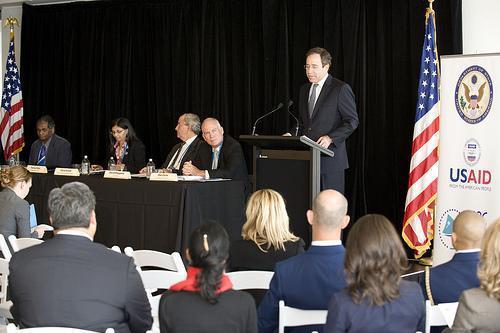How many people are standing?
Give a very brief answer. 1. 